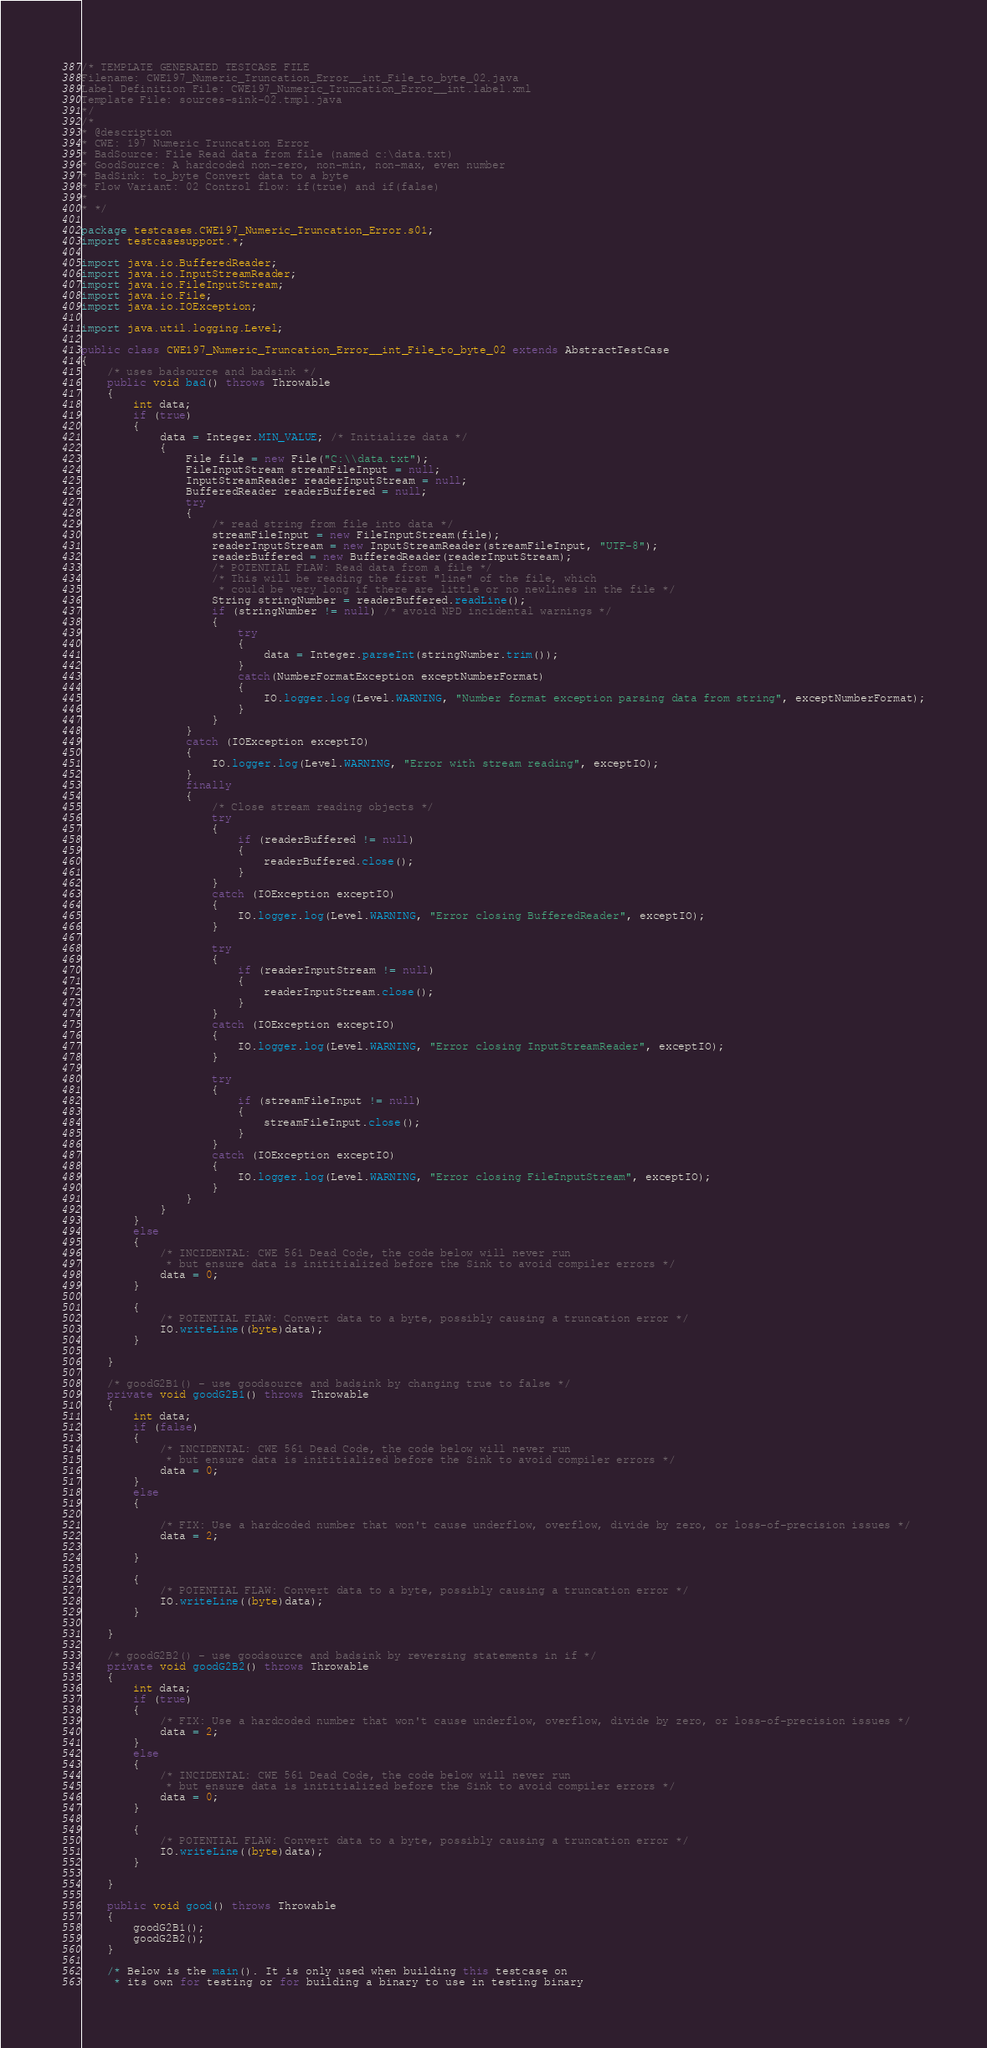<code> <loc_0><loc_0><loc_500><loc_500><_Java_>/* TEMPLATE GENERATED TESTCASE FILE
Filename: CWE197_Numeric_Truncation_Error__int_File_to_byte_02.java
Label Definition File: CWE197_Numeric_Truncation_Error__int.label.xml
Template File: sources-sink-02.tmpl.java
*/
/*
* @description
* CWE: 197 Numeric Truncation Error
* BadSource: File Read data from file (named c:\data.txt)
* GoodSource: A hardcoded non-zero, non-min, non-max, even number
* BadSink: to_byte Convert data to a byte
* Flow Variant: 02 Control flow: if(true) and if(false)
*
* */

package testcases.CWE197_Numeric_Truncation_Error.s01;
import testcasesupport.*;

import java.io.BufferedReader;
import java.io.InputStreamReader;
import java.io.FileInputStream;
import java.io.File;
import java.io.IOException;

import java.util.logging.Level;

public class CWE197_Numeric_Truncation_Error__int_File_to_byte_02 extends AbstractTestCase
{
    /* uses badsource and badsink */
    public void bad() throws Throwable
    {
        int data;
        if (true)
        {
            data = Integer.MIN_VALUE; /* Initialize data */
            {
                File file = new File("C:\\data.txt");
                FileInputStream streamFileInput = null;
                InputStreamReader readerInputStream = null;
                BufferedReader readerBuffered = null;
                try
                {
                    /* read string from file into data */
                    streamFileInput = new FileInputStream(file);
                    readerInputStream = new InputStreamReader(streamFileInput, "UTF-8");
                    readerBuffered = new BufferedReader(readerInputStream);
                    /* POTENTIAL FLAW: Read data from a file */
                    /* This will be reading the first "line" of the file, which
                     * could be very long if there are little or no newlines in the file */
                    String stringNumber = readerBuffered.readLine();
                    if (stringNumber != null) /* avoid NPD incidental warnings */
                    {
                        try
                        {
                            data = Integer.parseInt(stringNumber.trim());
                        }
                        catch(NumberFormatException exceptNumberFormat)
                        {
                            IO.logger.log(Level.WARNING, "Number format exception parsing data from string", exceptNumberFormat);
                        }
                    }
                }
                catch (IOException exceptIO)
                {
                    IO.logger.log(Level.WARNING, "Error with stream reading", exceptIO);
                }
                finally
                {
                    /* Close stream reading objects */
                    try
                    {
                        if (readerBuffered != null)
                        {
                            readerBuffered.close();
                        }
                    }
                    catch (IOException exceptIO)
                    {
                        IO.logger.log(Level.WARNING, "Error closing BufferedReader", exceptIO);
                    }

                    try
                    {
                        if (readerInputStream != null)
                        {
                            readerInputStream.close();
                        }
                    }
                    catch (IOException exceptIO)
                    {
                        IO.logger.log(Level.WARNING, "Error closing InputStreamReader", exceptIO);
                    }

                    try
                    {
                        if (streamFileInput != null)
                        {
                            streamFileInput.close();
                        }
                    }
                    catch (IOException exceptIO)
                    {
                        IO.logger.log(Level.WARNING, "Error closing FileInputStream", exceptIO);
                    }
                }
            }
        }
        else
        {
            /* INCIDENTAL: CWE 561 Dead Code, the code below will never run
             * but ensure data is inititialized before the Sink to avoid compiler errors */
            data = 0;
        }

        {
            /* POTENTIAL FLAW: Convert data to a byte, possibly causing a truncation error */
            IO.writeLine((byte)data);
        }

    }

    /* goodG2B1() - use goodsource and badsink by changing true to false */
    private void goodG2B1() throws Throwable
    {
        int data;
        if (false)
        {
            /* INCIDENTAL: CWE 561 Dead Code, the code below will never run
             * but ensure data is inititialized before the Sink to avoid compiler errors */
            data = 0;
        }
        else
        {

            /* FIX: Use a hardcoded number that won't cause underflow, overflow, divide by zero, or loss-of-precision issues */
            data = 2;

        }

        {
            /* POTENTIAL FLAW: Convert data to a byte, possibly causing a truncation error */
            IO.writeLine((byte)data);
        }

    }

    /* goodG2B2() - use goodsource and badsink by reversing statements in if */
    private void goodG2B2() throws Throwable
    {
        int data;
        if (true)
        {
            /* FIX: Use a hardcoded number that won't cause underflow, overflow, divide by zero, or loss-of-precision issues */
            data = 2;
        }
        else
        {
            /* INCIDENTAL: CWE 561 Dead Code, the code below will never run
             * but ensure data is inititialized before the Sink to avoid compiler errors */
            data = 0;
        }

        {
            /* POTENTIAL FLAW: Convert data to a byte, possibly causing a truncation error */
            IO.writeLine((byte)data);
        }

    }

    public void good() throws Throwable
    {
        goodG2B1();
        goodG2B2();
    }

    /* Below is the main(). It is only used when building this testcase on
     * its own for testing or for building a binary to use in testing binary</code> 